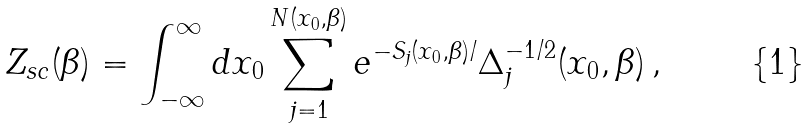<formula> <loc_0><loc_0><loc_500><loc_500>Z _ { s c } ( \beta ) = \int _ { - \infty } ^ { \infty } d x _ { 0 } \sum _ { j = 1 } ^ { N ( x _ { 0 } , \beta ) } e ^ { - S _ { j } ( x _ { 0 } , \beta ) / } \Delta _ { j } ^ { - 1 / 2 } ( x _ { 0 } , \beta ) \, ,</formula> 